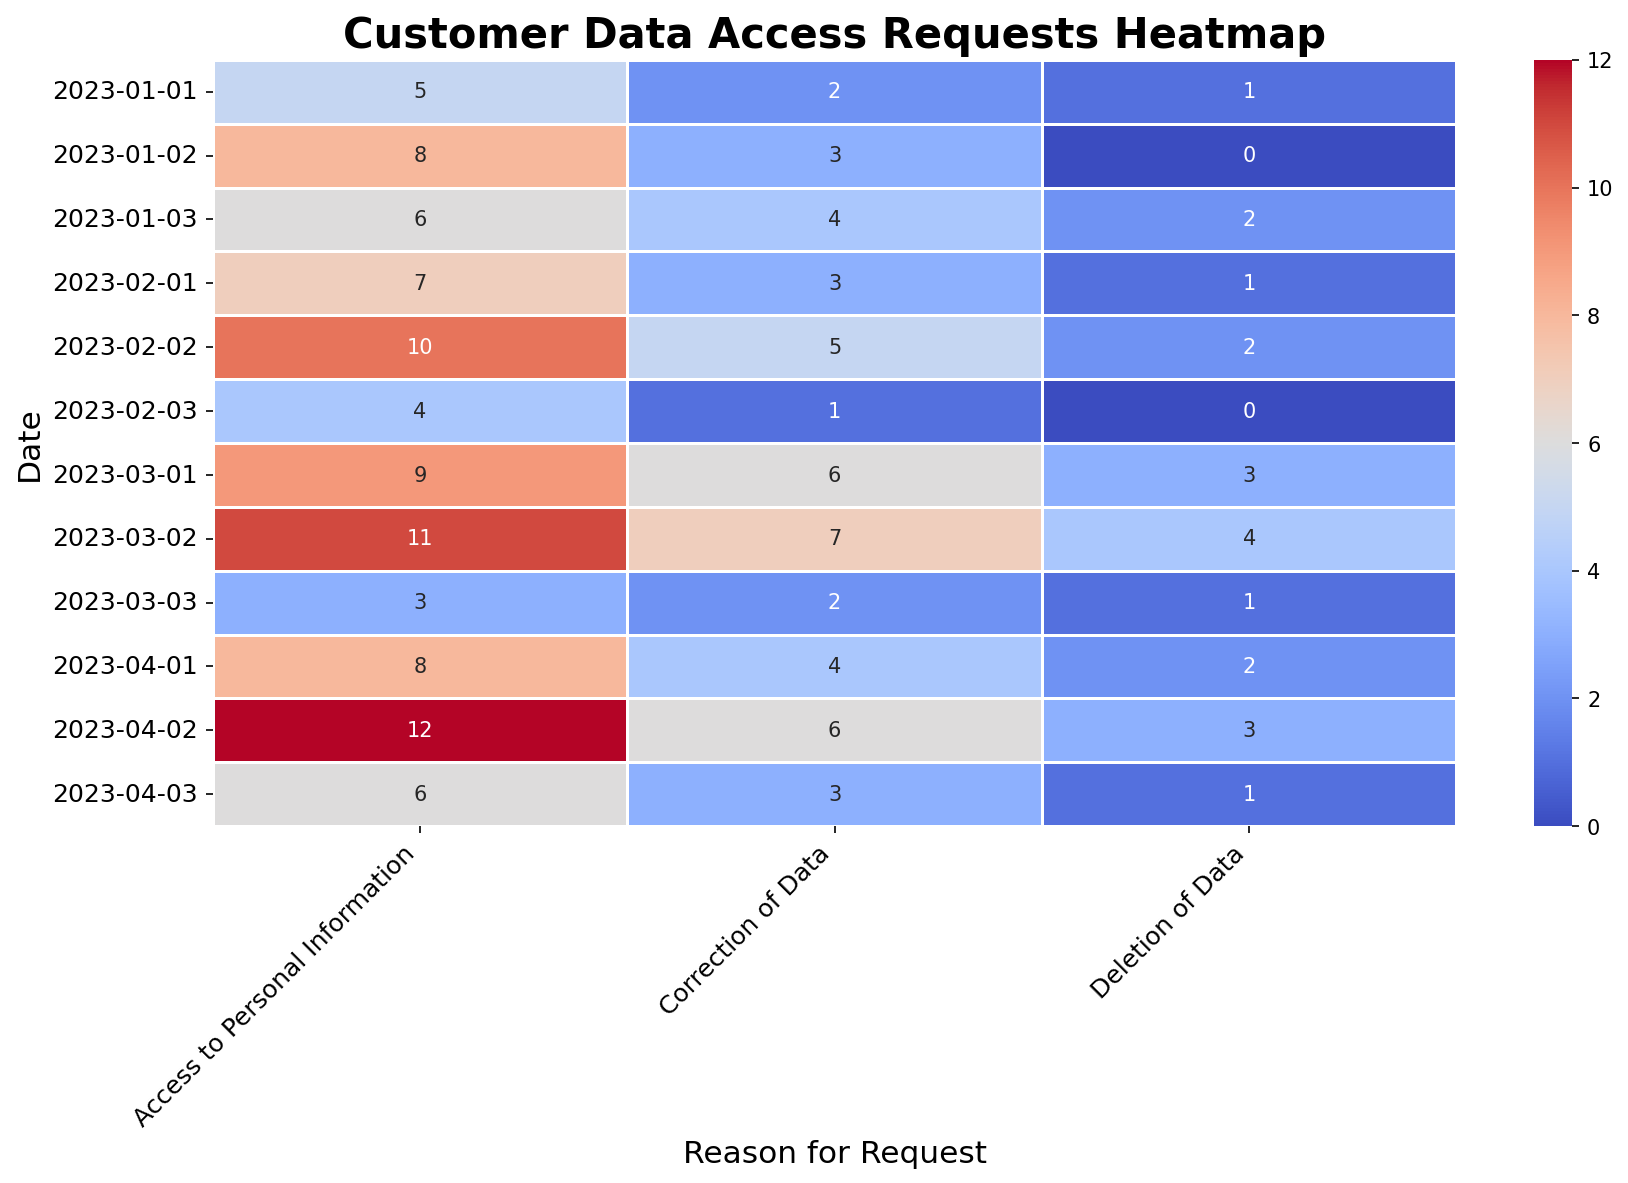Which date had the highest number of "Access to Personal Information" requests? Look at the column for "Access to Personal Information" and identify the maximum value. The highest number is 12, which corresponds to the date 2023-04-02.
Answer: 2023-04-02 What is the total number of "Correction of Data" requests in the month of January 2023? Sum the values in the "Correction of Data" column for the dates in January 2023: 2 (2023-01-01) + 3 (2023-01-02) + 4 (2023-01-03) equals 9.
Answer: 9 Compare the number of "Deletion of Data" requests on 2023-02-02 and 2023-03-02. Which is higher? Look at the values for "Deletion of Data" on both dates: 2023-02-02 has 2, and 2023-03-02 has 4. 4 is greater than 2, so 2023-03-02 is higher.
Answer: 2023-03-02 By how much did the "Access to Personal Information" requests increase from 2023-01-01 to 2023-02-01? Subtract the number of requests on 2023-01-01 from 2023-02-01: 7 (2023-02-01) - 5 (2023-01-01) equals 2.
Answer: 2 Which type of request had the most significant increase between 2023-01-02 and 2023-03-02? Compare the increase for each type of request between these dates: 
"Access to Personal Information": 11 - 8 = 3 
"Correction of Data": 7 - 3 = 4 
"Deletion of Data": 4 - 0 = 4. 
Both "Correction of Data" and "Deletion of Data" had the same increase of 4.
Answer: Correction of Data and Deletion of Data Is the frequency of "Access to Personal Information" requests on 2023-04-02 higher than the total number of any other request type on the same day? Compare 12 ("Access to Personal Information" on 2023-04-02) with frequencies of other request types on the same day: 6 (Correction of Data) and 3 (Deletion of Data). 12 is indeed higher than both 6 and 3.
Answer: Yes What is the average number of "Deletion of Data" requests per day in March 2023? There are 3 days in March 2023: 
"Deletion of Data" requests: 3 (2023-03-01), 4 (2023-03-02), and 1 (2023-03-03). 
The total is 3 + 4 + 1 = 8. The average is 8 / 3 ≈ 2.67.
Answer: 2.67 Between which two consecutive dates did the "Correction of Data" requests experience the highest increase? Calculate the change for each consecutive pair: 
2023-01-01 to 2023-01-02: 3 - 2 = 1 
2023-01-02 to 2023-01-03: 4 - 3 = 1 
2023-01-03 to 2023-02-01: 3 - 4 = -1 
2023-02-01 to 2023-02-02: 5 - 3 = 2 
2023-02-02 to 2023-02-03: 1 - 5 = -4 
2023-02-03 to 2023-03-01: 6 - 1 = 5 
2023-03-01 to 2023-03-02: 7 - 6 = 1 
2023-03-02 to 2023-03-03: 2 - 7 = -5 
2023-04-01 to 2023-04-02: 6 - 4 = 2 
2023-04-02 to 2023-04-03: 3 - 6 = -3. 
The highest increase is from 2023-02-03 to 2023-03-01 (5).
Answer: 2023-02-03 to 2023-03-01 